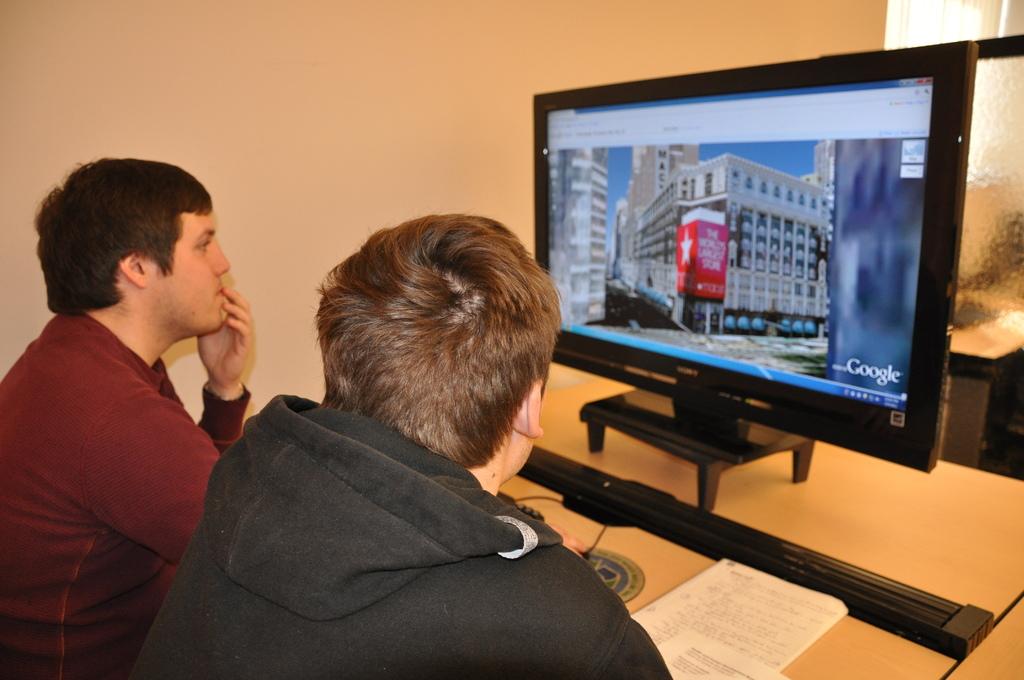What brand of computer monitor is this?
Provide a succinct answer. Sony. 